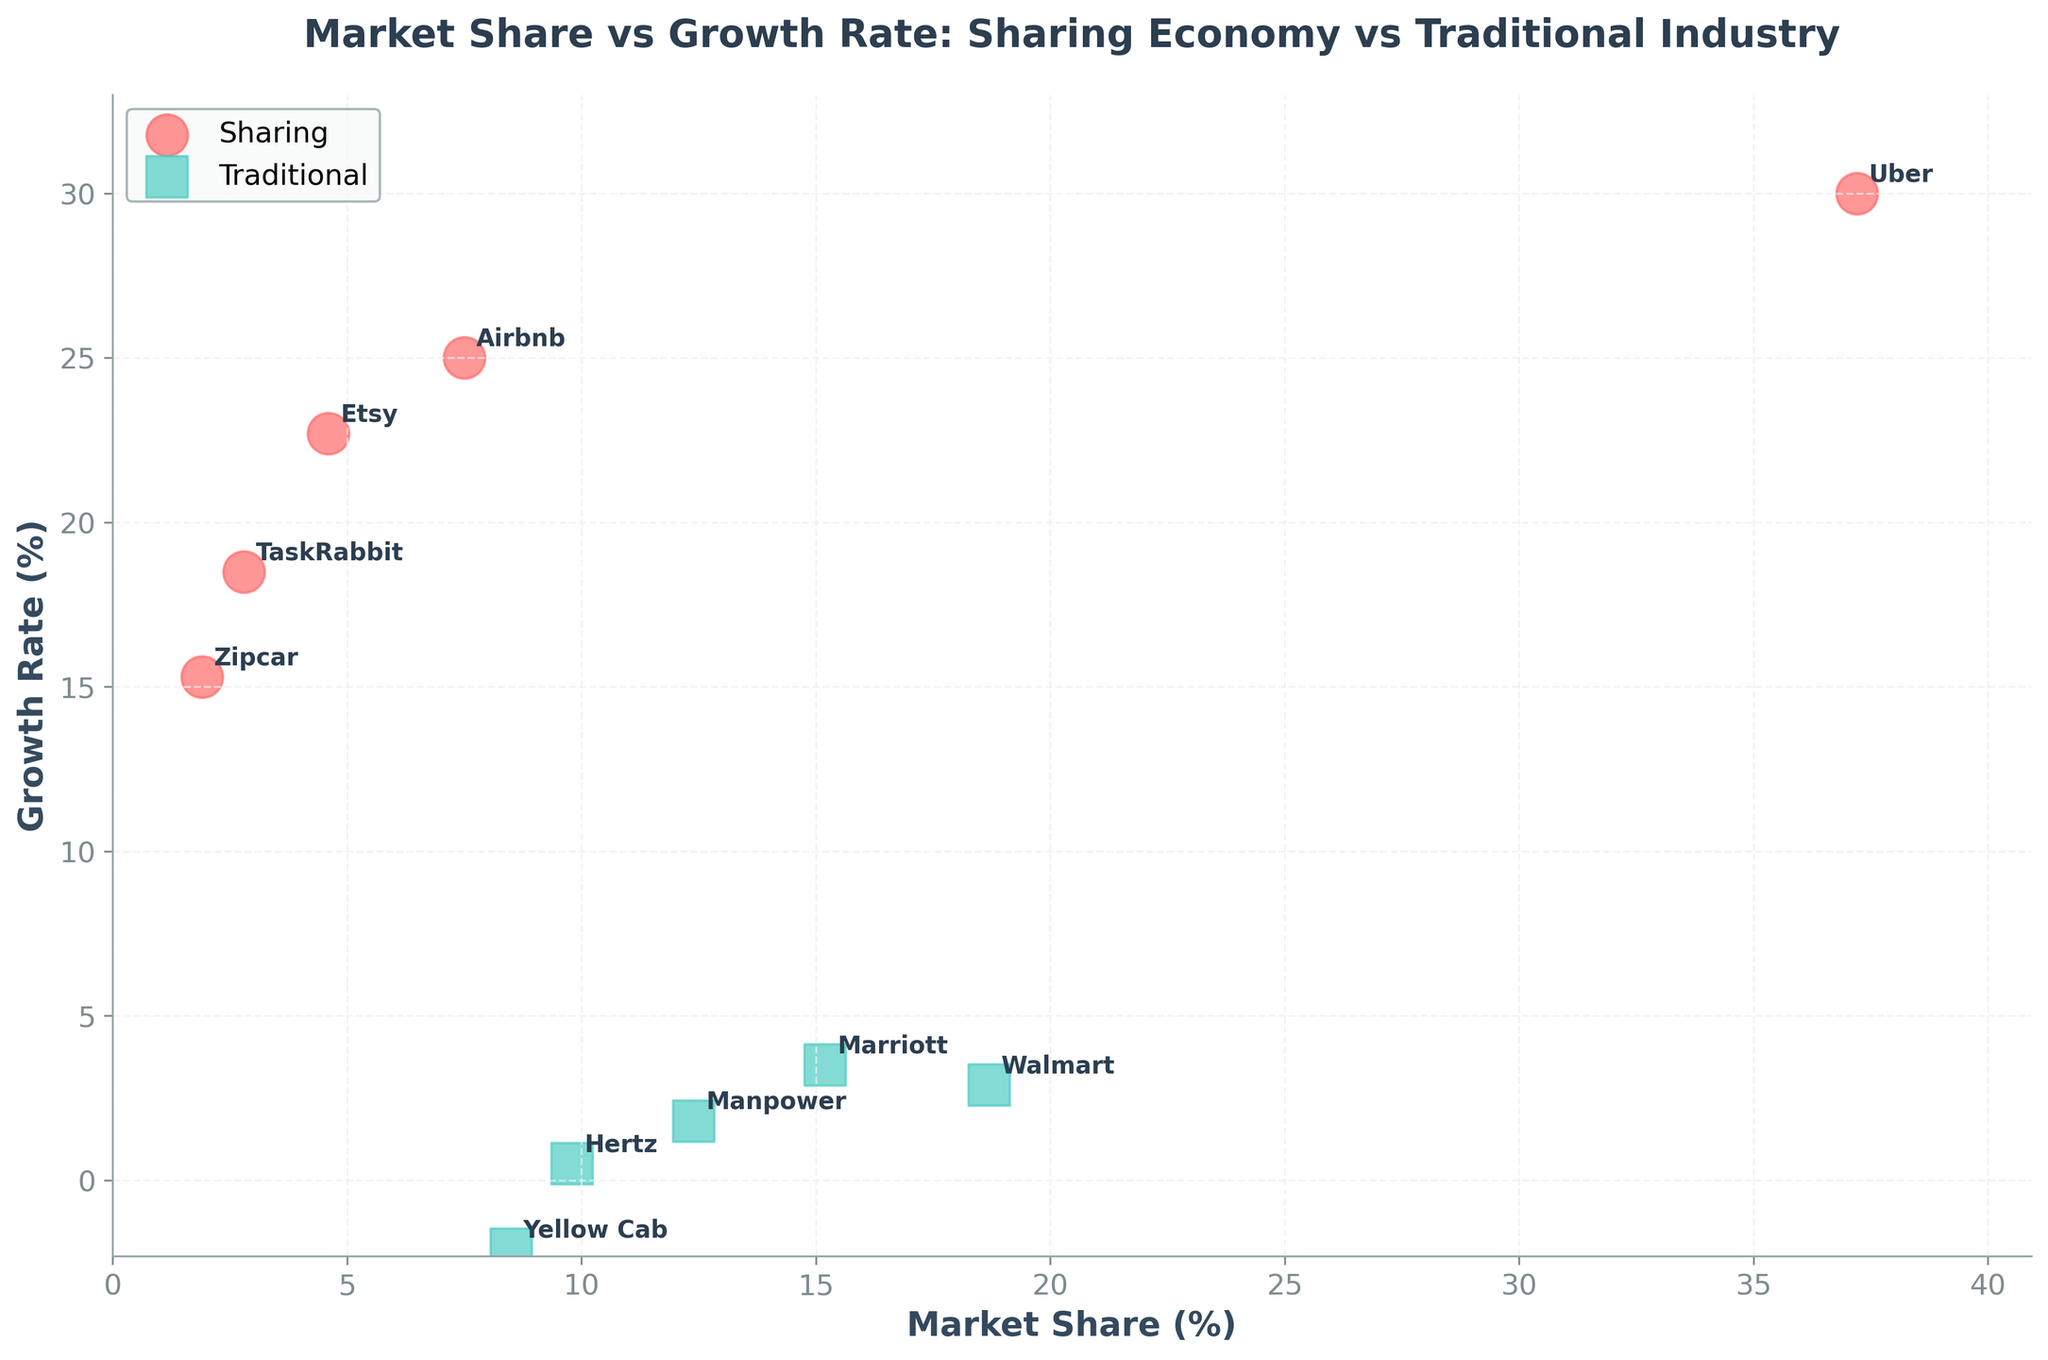What is the title of the figure? The title of the figure is displayed at the top of the plot in bold. It helps identify the main focus of the biplot.
Answer: Market Share vs Growth Rate: Sharing Economy vs Traditional Industry What are the colors used for the different types of companies? The biplot uses two distinct colors to differentiate between sharing economy platforms and traditional industry counterparts. Sharing companies are marked in red, and traditional companies are marked in teal.
Answer: Red for Sharing, Teal for Traditional How many data points represent sharing economy platforms? By counting the number of red (sharing economy) markers on the biplot, we can determine how many data points represent sharing economy platforms. There are 5 such markers: Airbnb, Uber, TaskRabbit, Etsy, and Zipcar.
Answer: 5 Which company has the highest growth rate? Observing the vertical axis, we look for the data point with the highest position. Uber has the highest growth rate at 30%.
Answer: Uber What is the range of market share for traditional industry companies? The market share ranges can be determined by finding the lowest and highest market share values among traditional companies. Traditional companies' market shares range from 8.5% (Yellow Cab) to 18.7% (Walmart).
Answer: 8.5% to 18.7% Which type of industry generally has higher growth rates? Comparing the vertical positions of red (sharing) and teal (traditional) markers, we notice that sharing companies are generally placed higher, indicating higher growth rates.
Answer: Sharing What is the difference in growth rate between Uber and Yellow Cab? Uber's growth rate is 30%, while Yellow Cab's is -2.1%. The difference is calculated as 30 - (-2.1) = 32.1%.
Answer: 32.1% Can you identify any companies with a negative growth rate? A negative growth rate would be indicated by a marker below the horizontal axis. Yellow Cab is the only company with a negative growth rate of -2.1%.
Answer: Yellow Cab What is the average market share of the companies in the sharing economy? Summing the market shares of all sharing companies (Airbnb: 7.5, Uber: 37.2, TaskRabbit: 2.8, Etsy: 4.6, Zipcar: 1.9) gives 54.0. Dividing by the number of companies (5) results in an average of 54.0 / 5 = 10.8%.
Answer: 10.8% Which traditional company has the lowest growth rate, and what is it? By checking the vertical positions of the teal markers representing traditional companies, Hertz has the lowest growth rate at 0.5%.
Answer: Hertz, 0.5% 